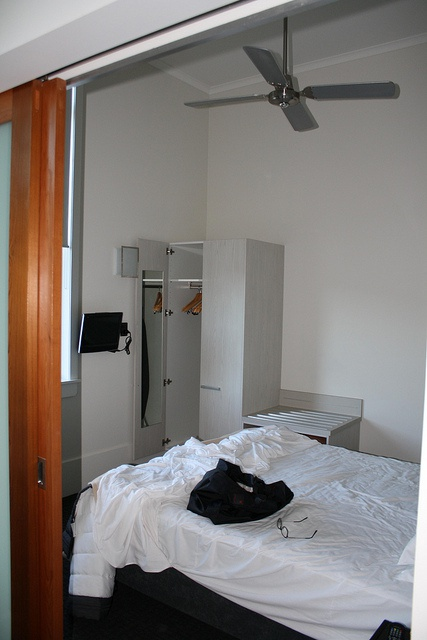Describe the objects in this image and their specific colors. I can see bed in darkgray, black, and lightgray tones, backpack in darkgray, black, and gray tones, and tv in darkgray, black, gray, and white tones in this image. 